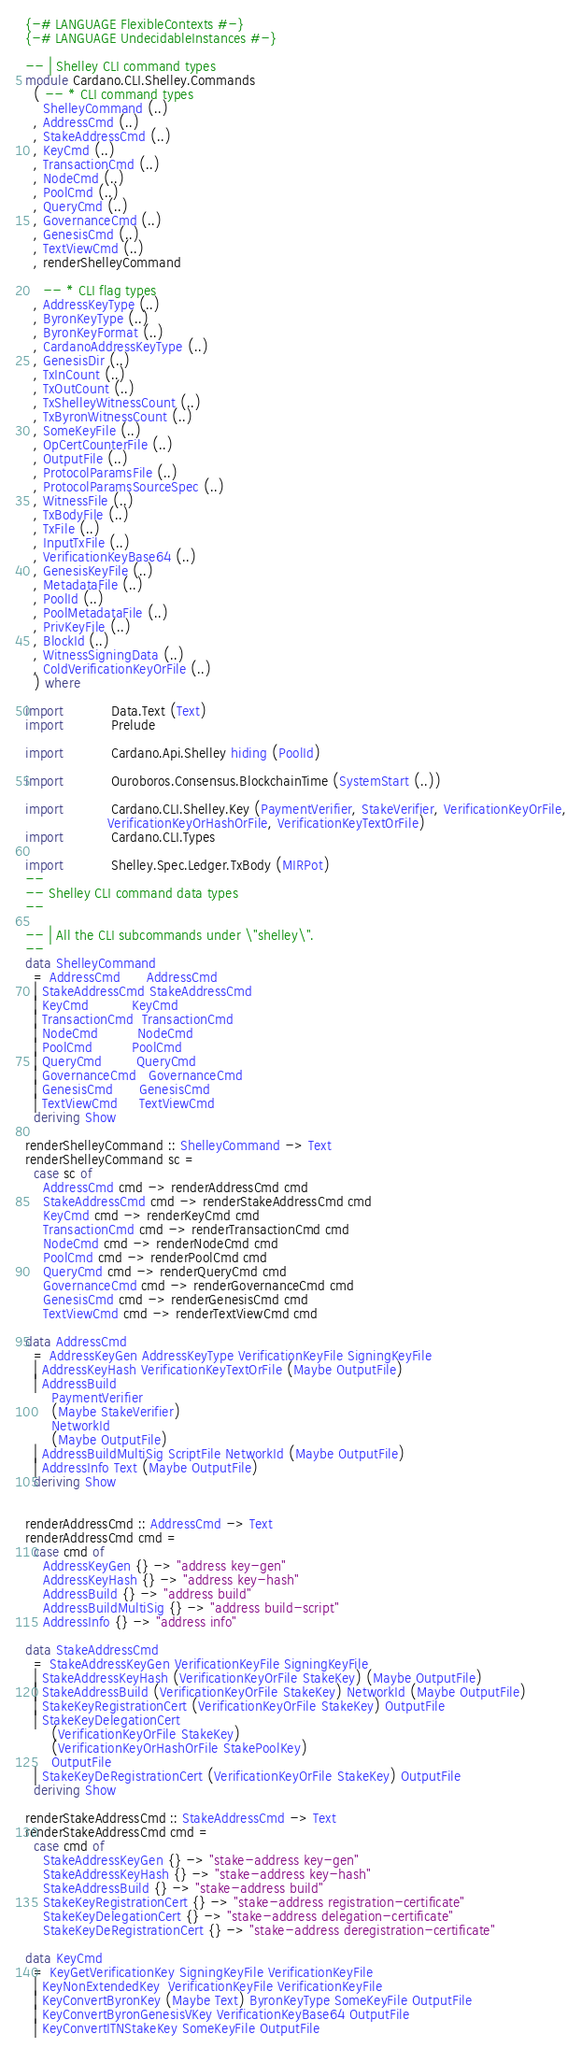Convert code to text. <code><loc_0><loc_0><loc_500><loc_500><_Haskell_>{-# LANGUAGE FlexibleContexts #-}
{-# LANGUAGE UndecidableInstances #-}

-- | Shelley CLI command types
module Cardano.CLI.Shelley.Commands
  ( -- * CLI command types
    ShelleyCommand (..)
  , AddressCmd (..)
  , StakeAddressCmd (..)
  , KeyCmd (..)
  , TransactionCmd (..)
  , NodeCmd (..)
  , PoolCmd (..)
  , QueryCmd (..)
  , GovernanceCmd (..)
  , GenesisCmd (..)
  , TextViewCmd (..)
  , renderShelleyCommand

    -- * CLI flag types
  , AddressKeyType (..)
  , ByronKeyType (..)
  , ByronKeyFormat (..)
  , CardanoAddressKeyType (..)
  , GenesisDir (..)
  , TxInCount (..)
  , TxOutCount (..)
  , TxShelleyWitnessCount (..)
  , TxByronWitnessCount (..)
  , SomeKeyFile (..)
  , OpCertCounterFile (..)
  , OutputFile (..)
  , ProtocolParamsFile (..)
  , ProtocolParamsSourceSpec (..)
  , WitnessFile (..)
  , TxBodyFile (..)
  , TxFile (..)
  , InputTxFile (..)
  , VerificationKeyBase64 (..)
  , GenesisKeyFile (..)
  , MetadataFile (..)
  , PoolId (..)
  , PoolMetadataFile (..)
  , PrivKeyFile (..)
  , BlockId (..)
  , WitnessSigningData (..)
  , ColdVerificationKeyOrFile (..)
  ) where

import           Data.Text (Text)
import           Prelude

import           Cardano.Api.Shelley hiding (PoolId)

import           Ouroboros.Consensus.BlockchainTime (SystemStart (..))

import           Cardano.CLI.Shelley.Key (PaymentVerifier, StakeVerifier, VerificationKeyOrFile,
                   VerificationKeyOrHashOrFile, VerificationKeyTextOrFile)
import           Cardano.CLI.Types

import           Shelley.Spec.Ledger.TxBody (MIRPot)
--
-- Shelley CLI command data types
--

-- | All the CLI subcommands under \"shelley\".
--
data ShelleyCommand
  = AddressCmd      AddressCmd
  | StakeAddressCmd StakeAddressCmd
  | KeyCmd          KeyCmd
  | TransactionCmd  TransactionCmd
  | NodeCmd         NodeCmd
  | PoolCmd         PoolCmd
  | QueryCmd        QueryCmd
  | GovernanceCmd   GovernanceCmd
  | GenesisCmd      GenesisCmd
  | TextViewCmd     TextViewCmd
  deriving Show

renderShelleyCommand :: ShelleyCommand -> Text
renderShelleyCommand sc =
  case sc of
    AddressCmd cmd -> renderAddressCmd cmd
    StakeAddressCmd cmd -> renderStakeAddressCmd cmd
    KeyCmd cmd -> renderKeyCmd cmd
    TransactionCmd cmd -> renderTransactionCmd cmd
    NodeCmd cmd -> renderNodeCmd cmd
    PoolCmd cmd -> renderPoolCmd cmd
    QueryCmd cmd -> renderQueryCmd cmd
    GovernanceCmd cmd -> renderGovernanceCmd cmd
    GenesisCmd cmd -> renderGenesisCmd cmd
    TextViewCmd cmd -> renderTextViewCmd cmd

data AddressCmd
  = AddressKeyGen AddressKeyType VerificationKeyFile SigningKeyFile
  | AddressKeyHash VerificationKeyTextOrFile (Maybe OutputFile)
  | AddressBuild
      PaymentVerifier
      (Maybe StakeVerifier)
      NetworkId
      (Maybe OutputFile)
  | AddressBuildMultiSig ScriptFile NetworkId (Maybe OutputFile)
  | AddressInfo Text (Maybe OutputFile)
  deriving Show


renderAddressCmd :: AddressCmd -> Text
renderAddressCmd cmd =
  case cmd of
    AddressKeyGen {} -> "address key-gen"
    AddressKeyHash {} -> "address key-hash"
    AddressBuild {} -> "address build"
    AddressBuildMultiSig {} -> "address build-script"
    AddressInfo {} -> "address info"

data StakeAddressCmd
  = StakeAddressKeyGen VerificationKeyFile SigningKeyFile
  | StakeAddressKeyHash (VerificationKeyOrFile StakeKey) (Maybe OutputFile)
  | StakeAddressBuild (VerificationKeyOrFile StakeKey) NetworkId (Maybe OutputFile)
  | StakeKeyRegistrationCert (VerificationKeyOrFile StakeKey) OutputFile
  | StakeKeyDelegationCert
      (VerificationKeyOrFile StakeKey)
      (VerificationKeyOrHashOrFile StakePoolKey)
      OutputFile
  | StakeKeyDeRegistrationCert (VerificationKeyOrFile StakeKey) OutputFile
  deriving Show

renderStakeAddressCmd :: StakeAddressCmd -> Text
renderStakeAddressCmd cmd =
  case cmd of
    StakeAddressKeyGen {} -> "stake-address key-gen"
    StakeAddressKeyHash {} -> "stake-address key-hash"
    StakeAddressBuild {} -> "stake-address build"
    StakeKeyRegistrationCert {} -> "stake-address registration-certificate"
    StakeKeyDelegationCert {} -> "stake-address delegation-certificate"
    StakeKeyDeRegistrationCert {} -> "stake-address deregistration-certificate"

data KeyCmd
  = KeyGetVerificationKey SigningKeyFile VerificationKeyFile
  | KeyNonExtendedKey  VerificationKeyFile VerificationKeyFile
  | KeyConvertByronKey (Maybe Text) ByronKeyType SomeKeyFile OutputFile
  | KeyConvertByronGenesisVKey VerificationKeyBase64 OutputFile
  | KeyConvertITNStakeKey SomeKeyFile OutputFile</code> 